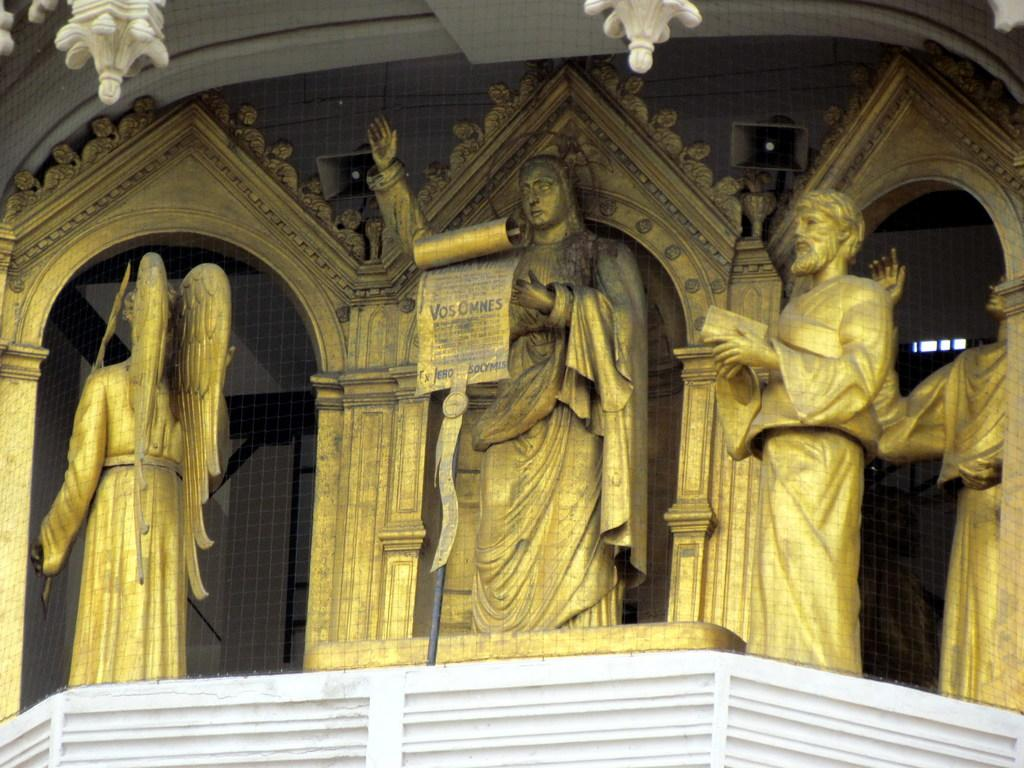What is located in the center of the image? There is a wall in the center of the image. What other structures can be seen in the image? There is a fence in the image. What type of object has a black and white color in the image? There is a black and white color object in the image. What type of figures are present in the image? There are statues in the image, and they are in a golden color. Are there any other objects in the image besides the wall, fence, and statues? Yes, there are other objects in the image. What can be seen on the wall in the image? There is a design on the wall. Can you tell me how many toes the manager has in the image? There is no manager or reference to toes in the image. 